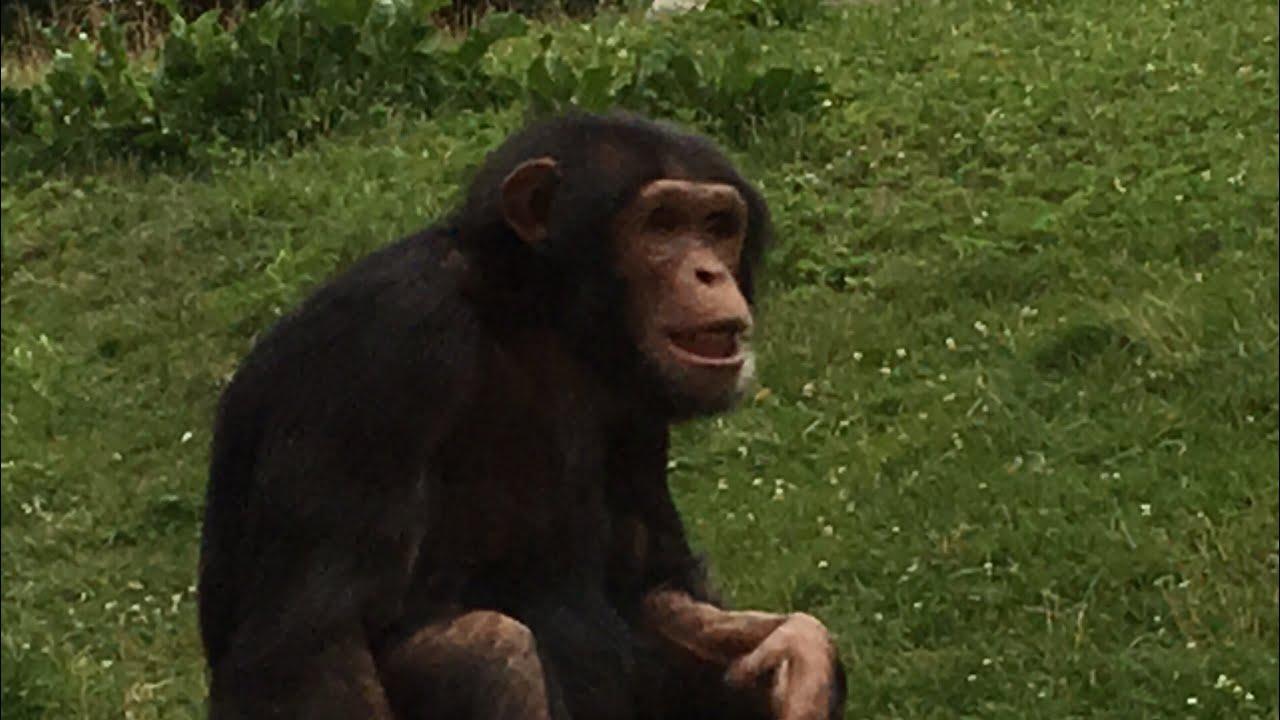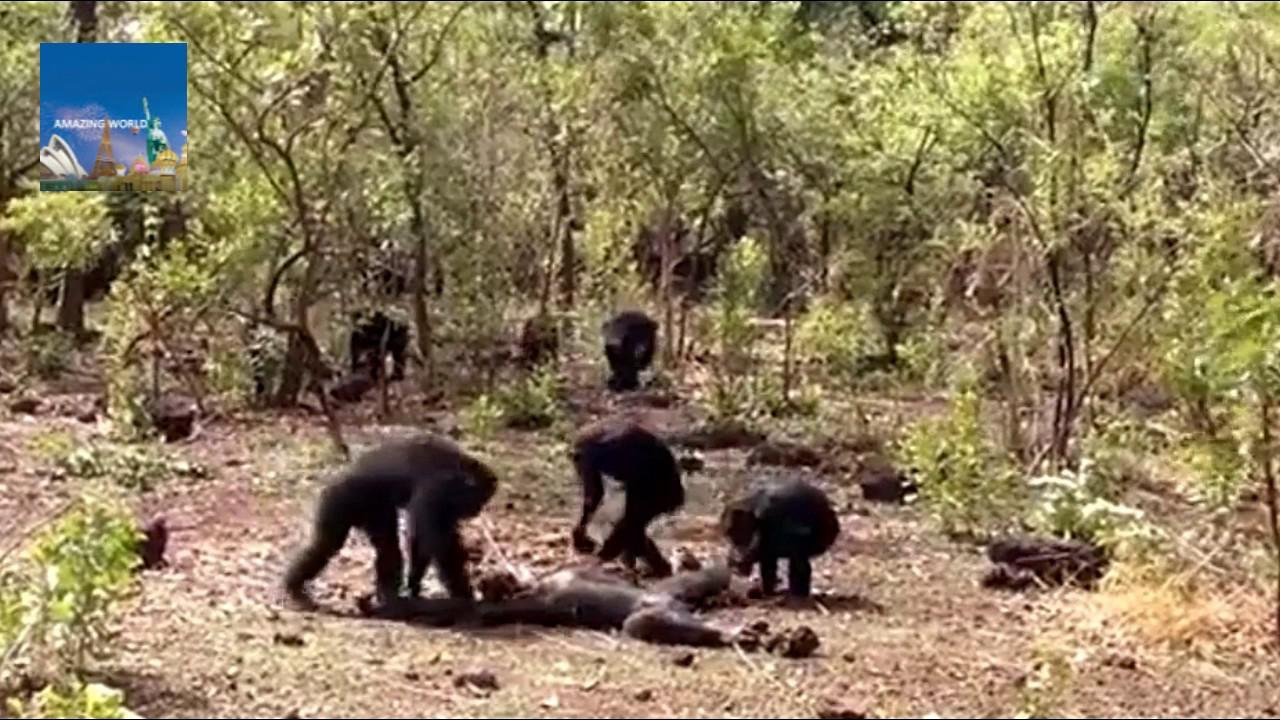The first image is the image on the left, the second image is the image on the right. Considering the images on both sides, is "There is a furniture near a chimpanzee in at least one of the images." valid? Answer yes or no. No. The first image is the image on the left, the second image is the image on the right. For the images displayed, is the sentence "One image shows multiple chimps gathered around a prone figure on the ground in a clearing." factually correct? Answer yes or no. Yes. 